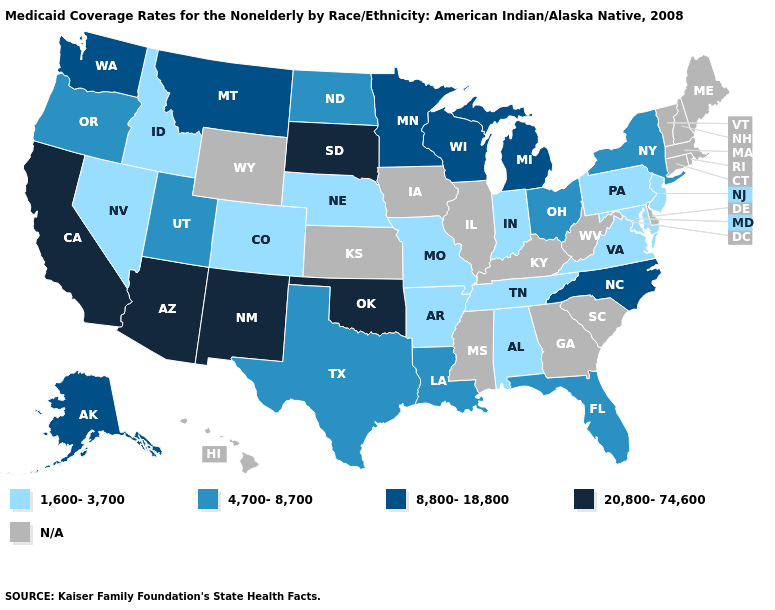How many symbols are there in the legend?
Quick response, please. 5. What is the value of Pennsylvania?
Be succinct. 1,600-3,700. What is the highest value in the MidWest ?
Concise answer only. 20,800-74,600. Name the states that have a value in the range 20,800-74,600?
Be succinct. Arizona, California, New Mexico, Oklahoma, South Dakota. What is the highest value in states that border Nevada?
Short answer required. 20,800-74,600. Does Louisiana have the highest value in the USA?
Answer briefly. No. Does New York have the lowest value in the Northeast?
Write a very short answer. No. Is the legend a continuous bar?
Write a very short answer. No. What is the value of Louisiana?
Give a very brief answer. 4,700-8,700. What is the value of California?
Concise answer only. 20,800-74,600. What is the highest value in states that border Wisconsin?
Give a very brief answer. 8,800-18,800. Among the states that border Kentucky , which have the lowest value?
Concise answer only. Indiana, Missouri, Tennessee, Virginia. Which states hav the highest value in the South?
Give a very brief answer. Oklahoma. What is the highest value in the MidWest ?
Short answer required. 20,800-74,600. 